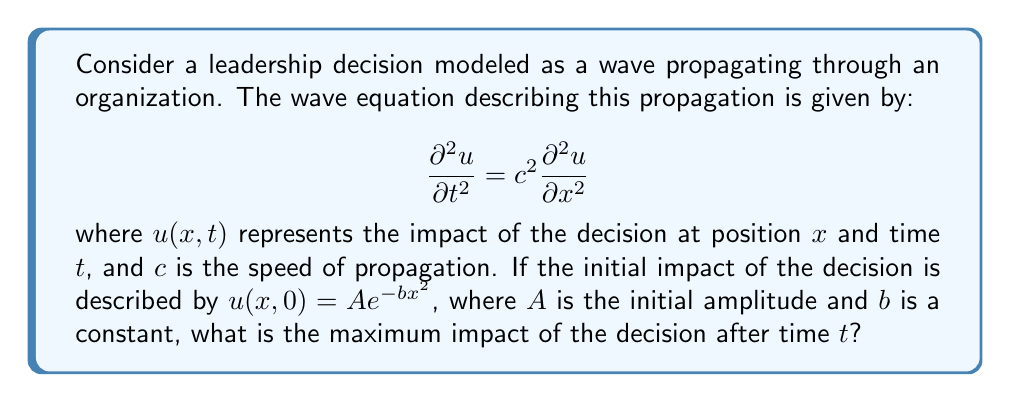Provide a solution to this math problem. To solve this problem, we need to follow these steps:

1) The general solution to the 1D wave equation is given by D'Alembert's formula:

   $$u(x,t) = \frac{1}{2}[f(x+ct) + f(x-ct)]$$

   where $f$ is determined by the initial conditions.

2) In our case, $f(x) = Ae^{-bx^2}$, so the solution becomes:

   $$u(x,t) = \frac{1}{2}[Ae^{-b(x+ct)^2} + Ae^{-b(x-ct)^2}]$$

3) To find the maximum impact, we need to find the maximum value of $u(x,t)$ for a given $t$. This occurs at $x=0$ due to the symmetry of the exponential function:

   $$u(0,t) = \frac{1}{2}[Ae^{-b(ct)^2} + Ae^{-b(-ct)^2}] = Ae^{-b(ct)^2}$$

4) This expression represents how the maximum impact decreases over time. The maximum impact at time $t$ is therefore:

   $$u_{max}(t) = Ae^{-b(ct)^2}$$

This formula shows that the maximum impact decreases exponentially with time, with the rate of decrease determined by the constants $b$ and $c$.
Answer: $Ae^{-b(ct)^2}$ 